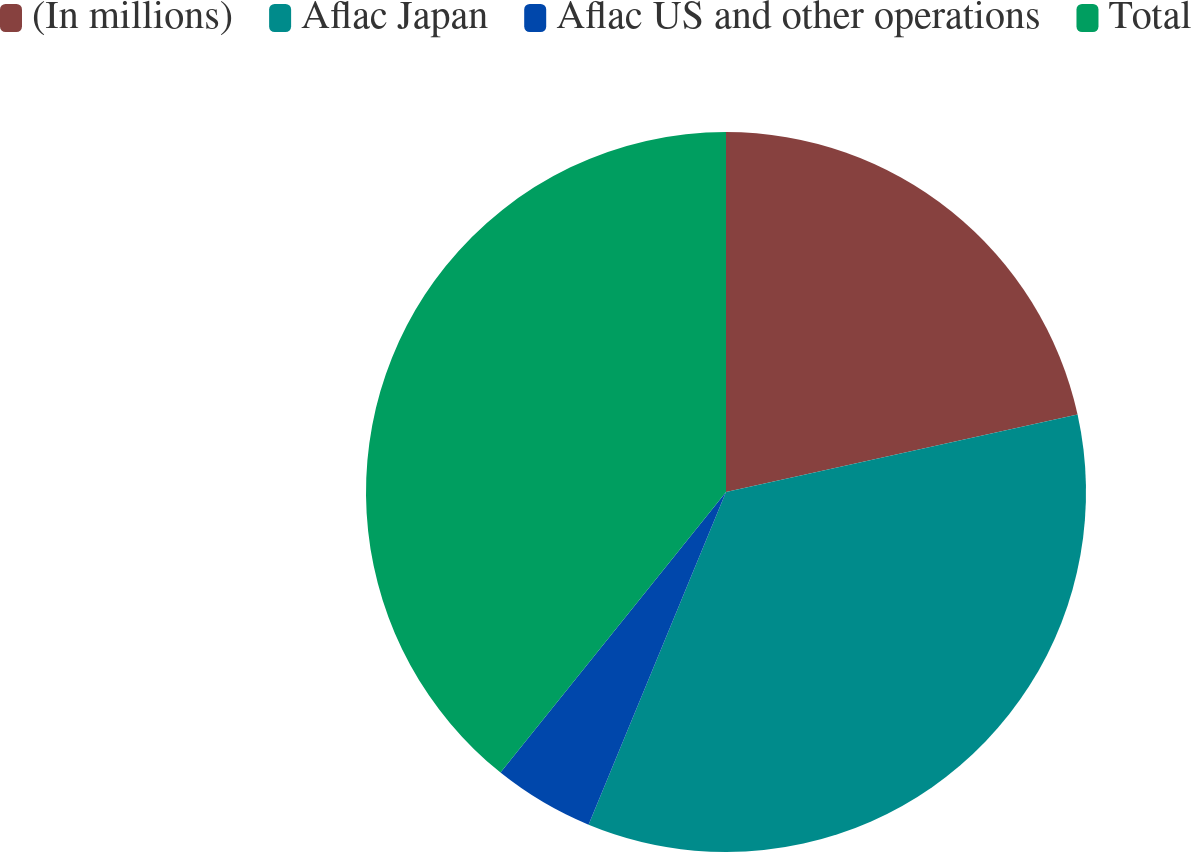Convert chart to OTSL. <chart><loc_0><loc_0><loc_500><loc_500><pie_chart><fcel>(In millions)<fcel>Aflac Japan<fcel>Aflac US and other operations<fcel>Total<nl><fcel>21.55%<fcel>34.69%<fcel>4.54%<fcel>39.23%<nl></chart> 